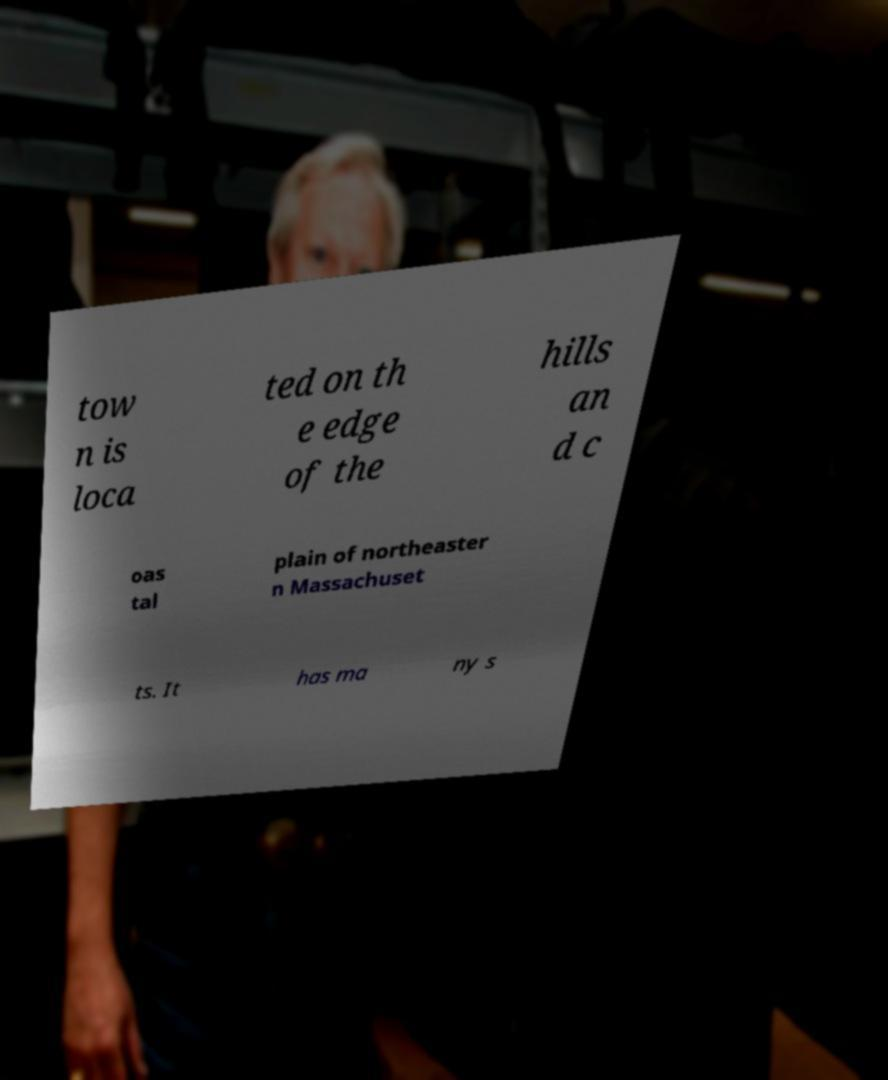Please read and relay the text visible in this image. What does it say? tow n is loca ted on th e edge of the hills an d c oas tal plain of northeaster n Massachuset ts. It has ma ny s 